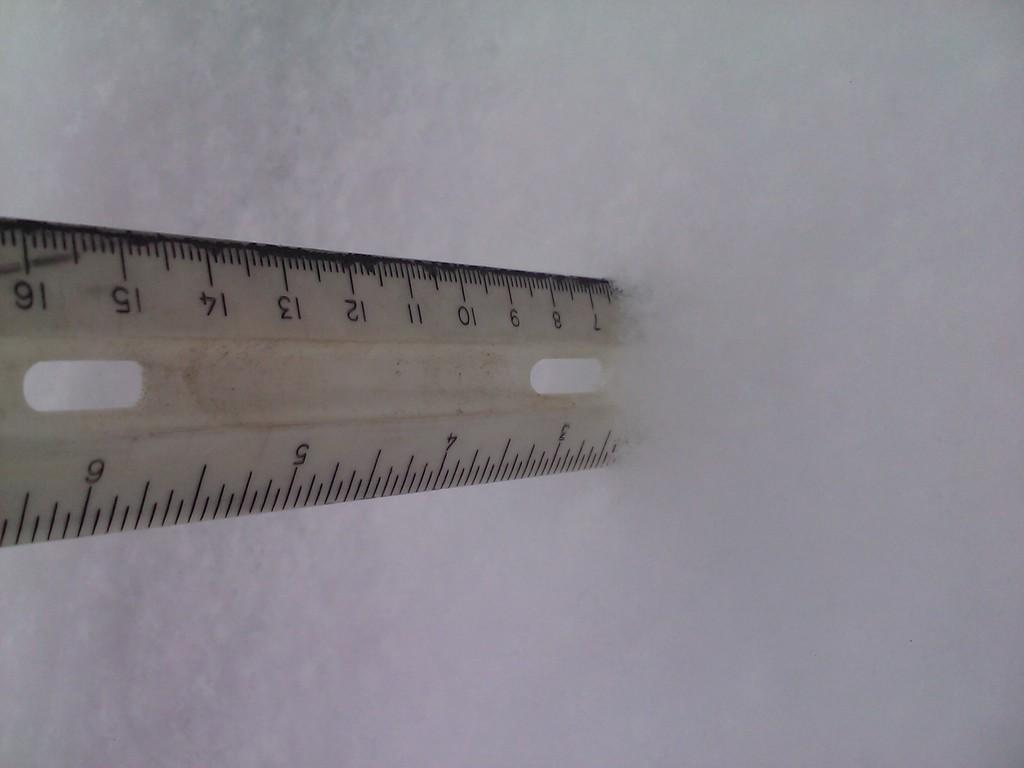<image>
Render a clear and concise summary of the photo. A wooden ruler is indicating that there are 2.5 inches of snow. 